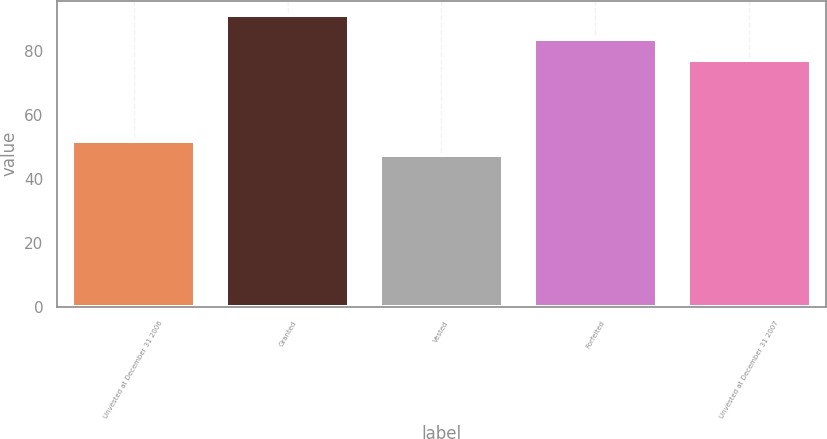<chart> <loc_0><loc_0><loc_500><loc_500><bar_chart><fcel>Unvested at December 31 2006<fcel>Granted<fcel>Vested<fcel>Forfeited<fcel>Unvested at December 31 2007<nl><fcel>51.83<fcel>91.13<fcel>47.46<fcel>83.91<fcel>77.21<nl></chart> 